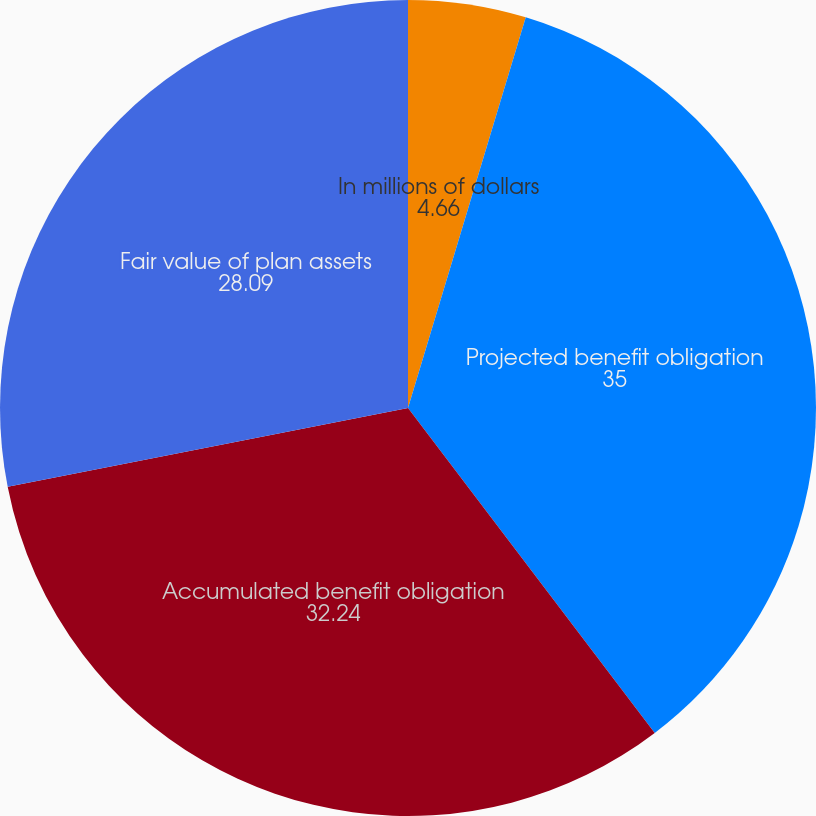Convert chart to OTSL. <chart><loc_0><loc_0><loc_500><loc_500><pie_chart><fcel>In millions of dollars<fcel>Projected benefit obligation<fcel>Accumulated benefit obligation<fcel>Fair value of plan assets<nl><fcel>4.66%<fcel>35.0%<fcel>32.24%<fcel>28.09%<nl></chart> 